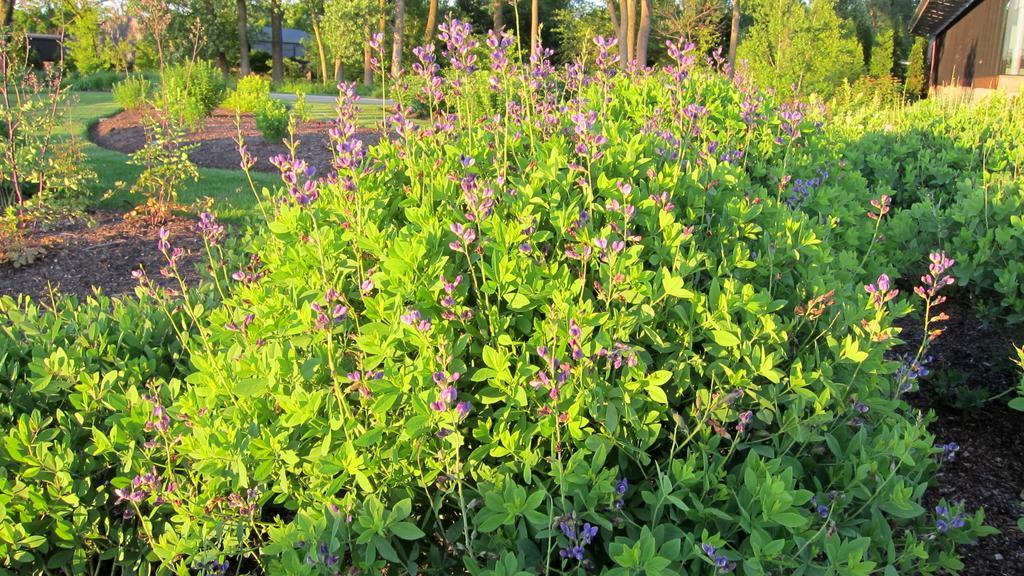Could you give a brief overview of what you see in this image? At the bottom of the picture, we see the plants which are flowering and these flowers are in purple color. Behind that, we see a brown color building. There are trees in the background and this picture is clicked in the garden. 